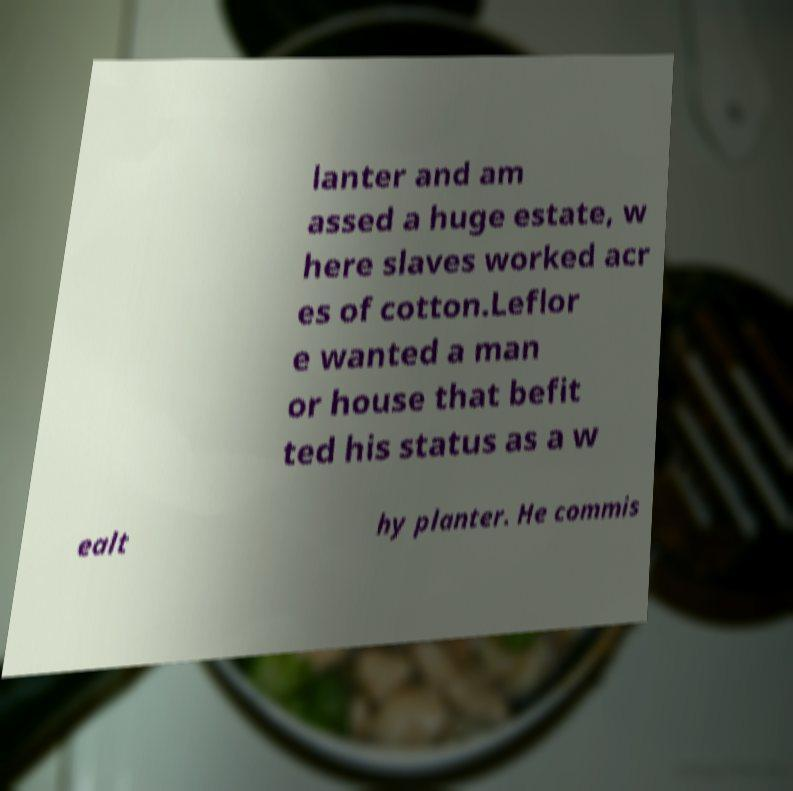There's text embedded in this image that I need extracted. Can you transcribe it verbatim? lanter and am assed a huge estate, w here slaves worked acr es of cotton.Leflor e wanted a man or house that befit ted his status as a w ealt hy planter. He commis 